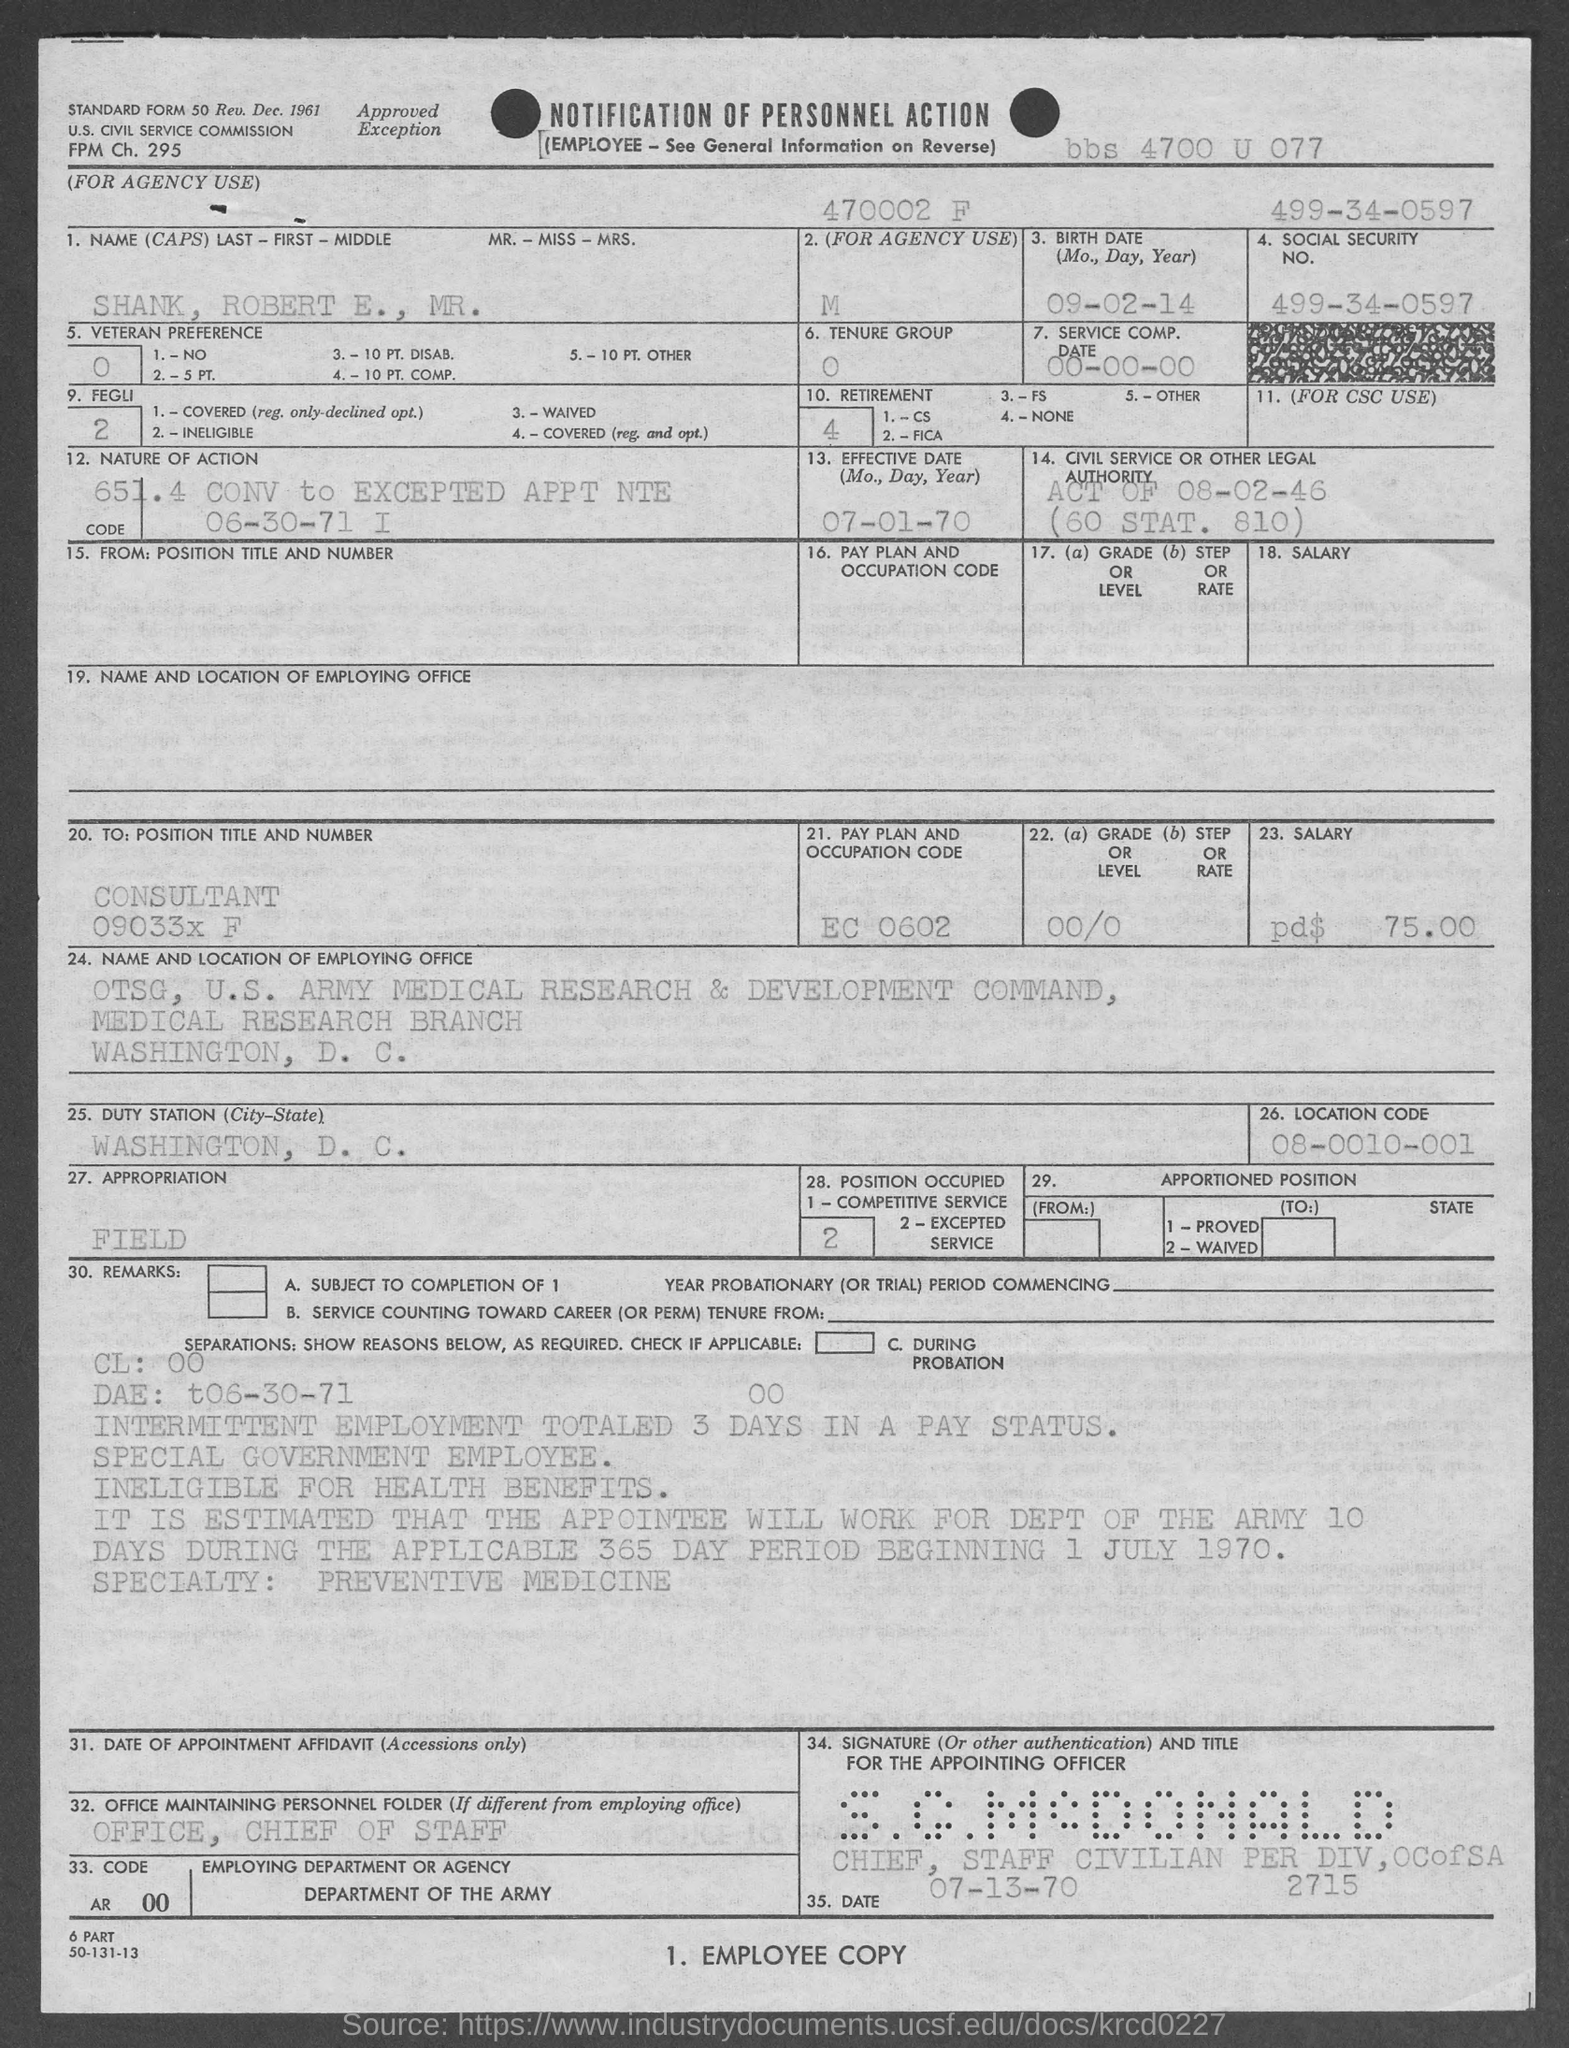What is the Standard Form No. given in the document?
Your answer should be compact. 50. What is the Social Security No. given in the form?
Make the answer very short. 499-34-0597. What is the Effective Date mentioned in the form?
Provide a short and direct response. 07-01-70. What is the name of the person given in the form?
Offer a very short reply. SHANK, ROBERT E., MR. What is the birth date of Mr. Robert E. Shank?
Your response must be concise. 09-02-14. What is the Service Comp. date mentioned in the form?
Your answer should be very brief. 00-00-00. What is the pay plan and occupation code mentioned in the form?
Your response must be concise. EC 0602. What is the position title and number of Mr. Robert E. Shank?
Your answer should be very brief. Consultant 09033x F. Which is the duty station of Mr. Robert E. Shank given in the form?
Provide a succinct answer. WASHINGTON, D. C. What is the location code given in the form?
Provide a succinct answer. 08-0010-001. 